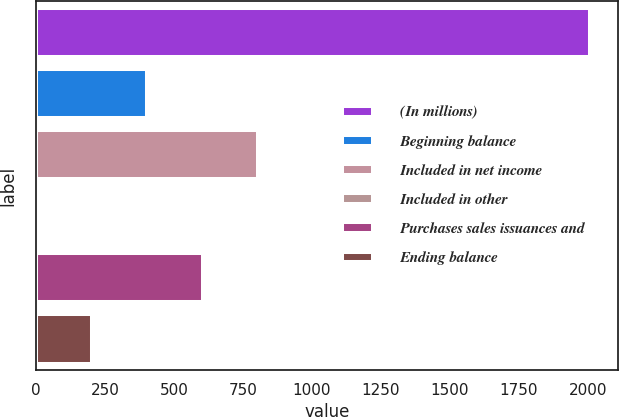<chart> <loc_0><loc_0><loc_500><loc_500><bar_chart><fcel>(In millions)<fcel>Beginning balance<fcel>Included in net income<fcel>Included in other<fcel>Purchases sales issuances and<fcel>Ending balance<nl><fcel>2009<fcel>402.6<fcel>804.2<fcel>1<fcel>603.4<fcel>201.8<nl></chart> 